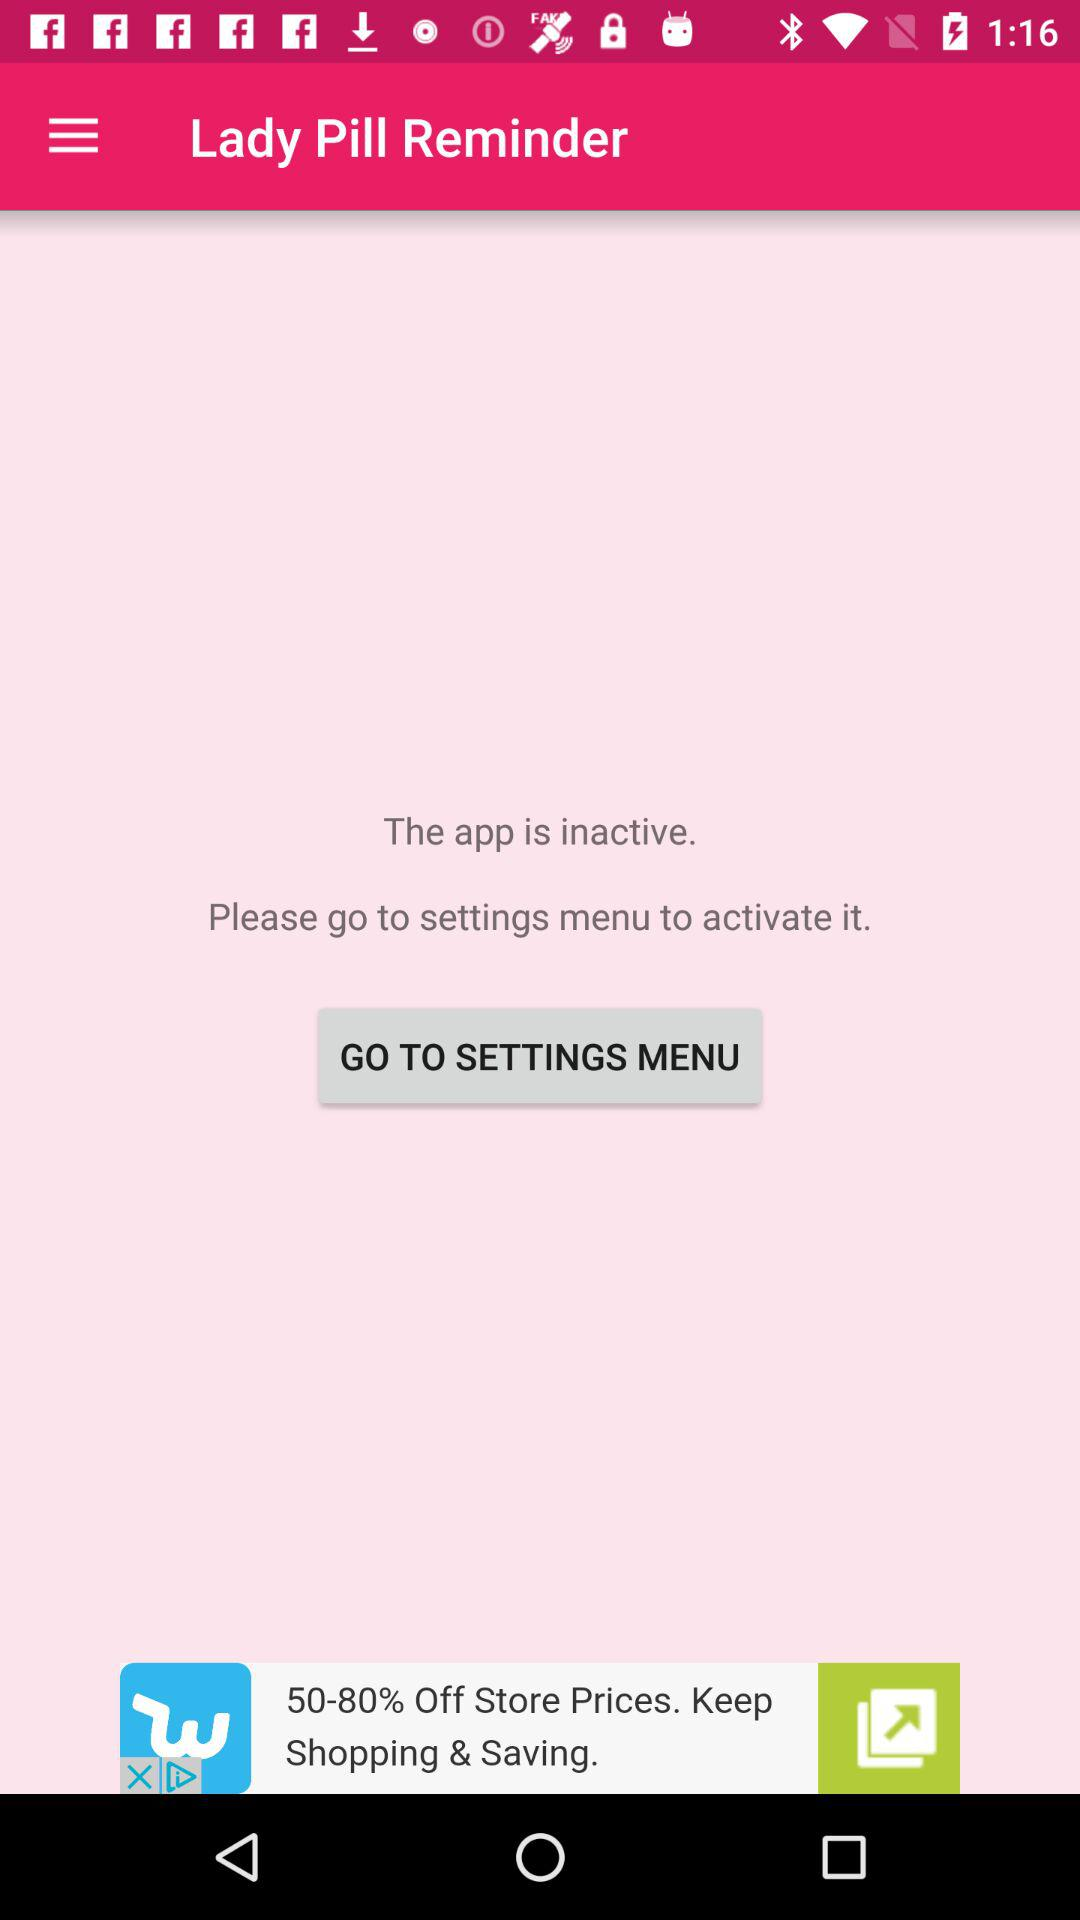What is the name of the application? The name of the application is "Lady Pill Reminder". 